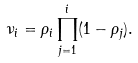Convert formula to latex. <formula><loc_0><loc_0><loc_500><loc_500>\nu _ { i } = \rho _ { i } \prod _ { j = 1 } ^ { i } ( 1 - \rho _ { j } ) .</formula> 